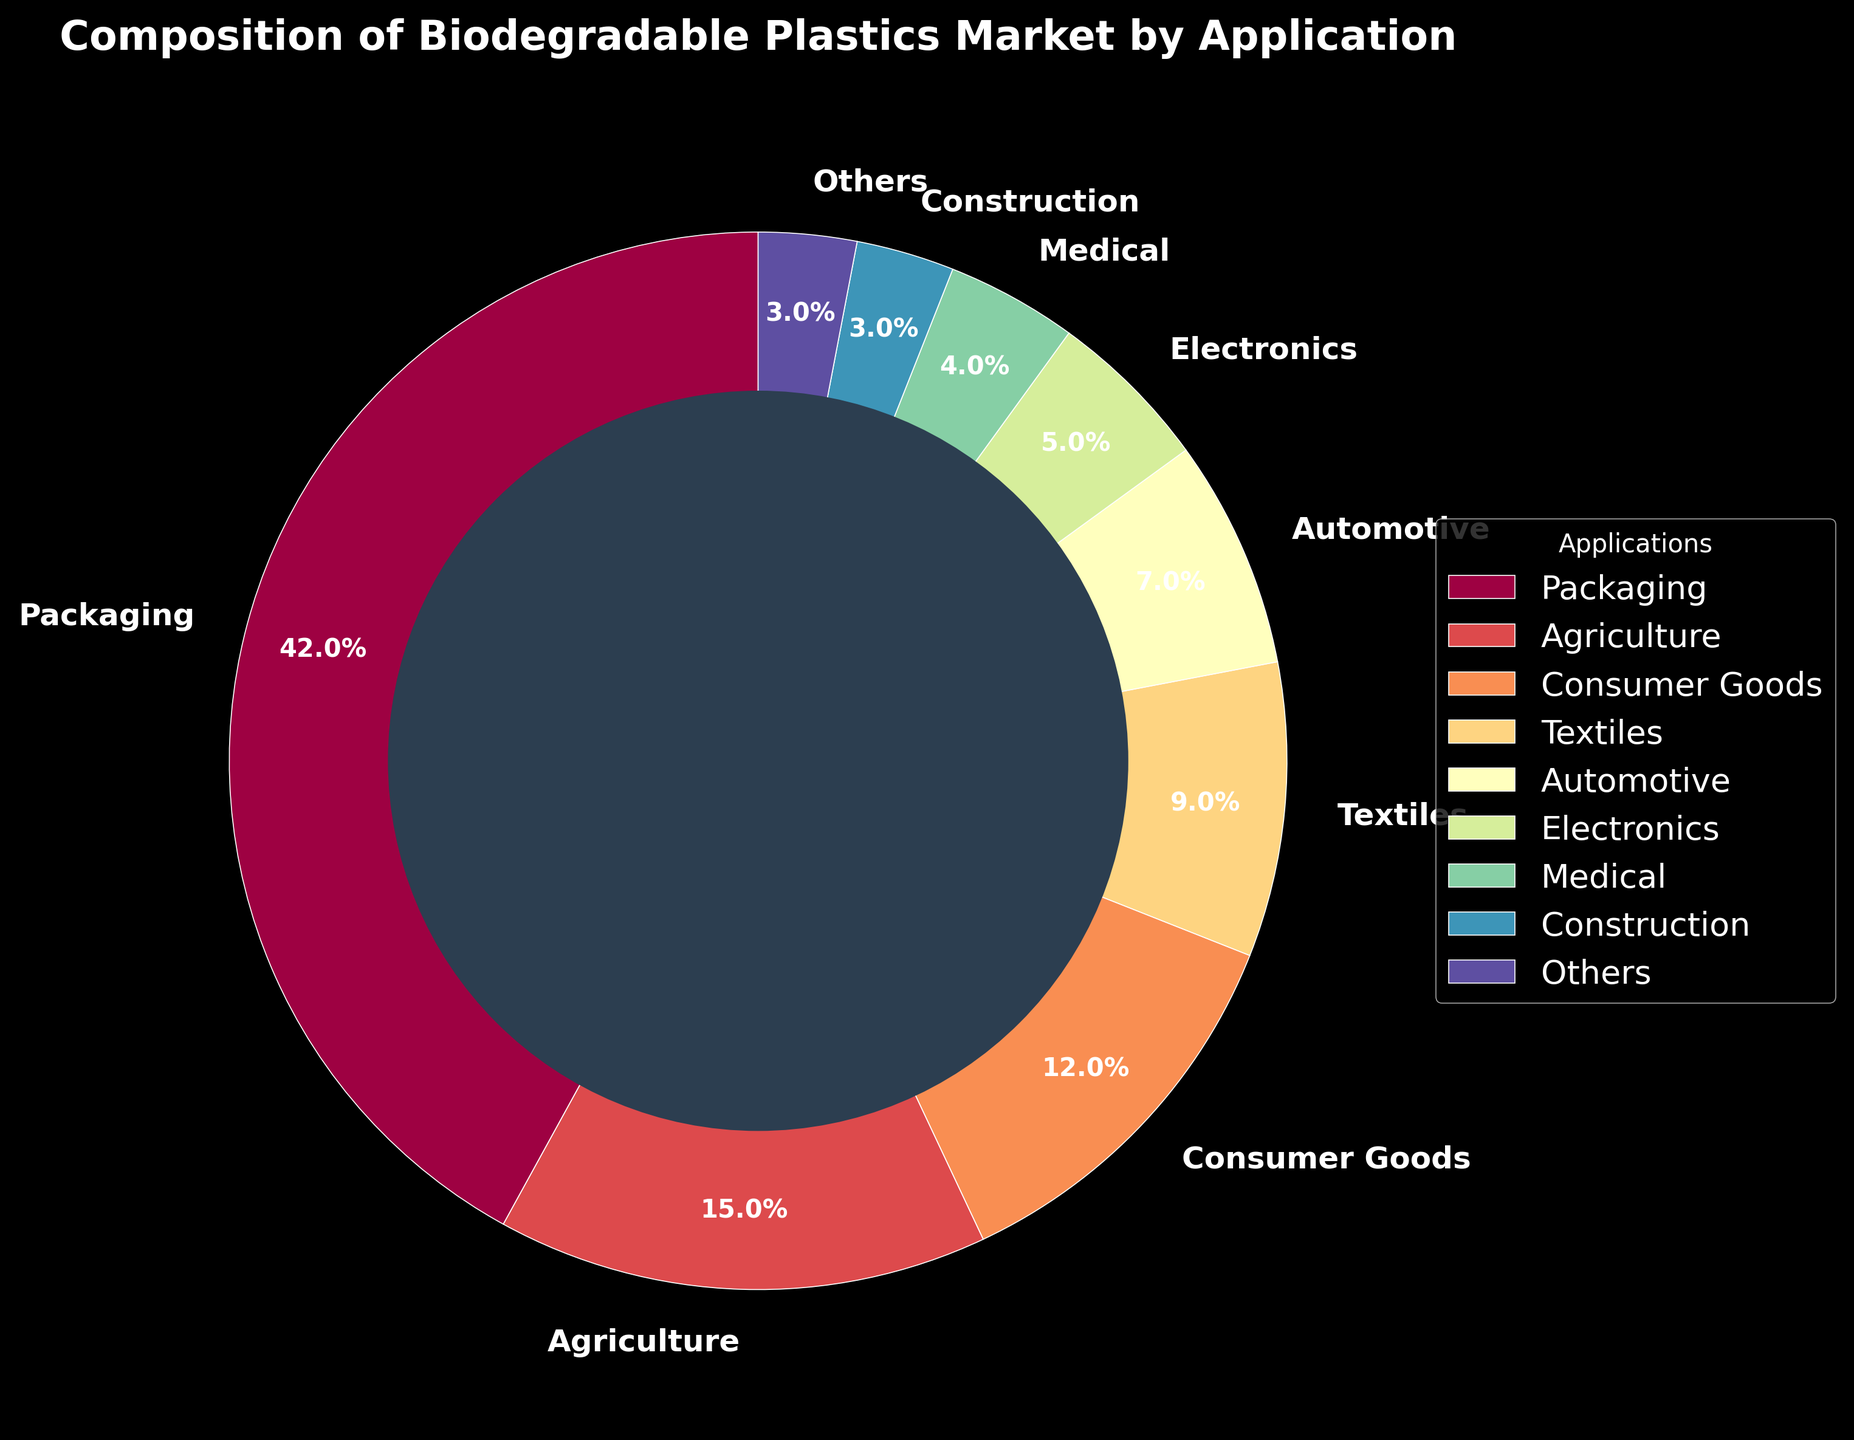Which application has the largest percentage of the biodegradable plastics market? The largest section in the pie chart is for Packaging, so Packaging has the largest percentage.
Answer: Packaging What percentage of the biodegradable plastics market does the Automotive and Medical applications together represent? Sum the percentages of Automotive (7%) and Medical (4%) applications. 7% + 4% = 11%
Answer: 11% How does the percentage of the Electronics application compare to the Consumer Goods application? The percentage for Electronics is 5%, and for Consumer Goods, it is 12%. 5% is less than 12%.
Answer: Less Calculate the total percentage of the biodegradable plastics market taken up by Textiles, Automotive, and Construction applications. Sum the percentages of Textiles (9%), Automotive (7%), and Construction (3%) applications. 9% + 7% + 3% = 19%
Answer: 19% What is the difference between the percentages of the Packaging and Agriculture applications? Subtract the percentage of Agriculture (15%) from Packaging (42%). 42% - 15% = 27%
Answer: 27% Which application constitutes the smallest percentage of the biodegradable plastics market, and what is that percentage? The smallest sections in the pie chart are for Construction and Others, each representing 3%.
Answer: Construction and Others, 3% What applications cumulatively take up more than 50% of the biodegradable plastics market? Sum percentages to find the total. Packaging (42%) + Agriculture (15%) = 57%, which is greater than 50%.
Answer: Packaging and Agriculture Compare the percentages provided for Medical and Others applications. Do they constitute the same percentage? The percentage for Medical is 4% and for Others is 3%. They are not the same.
Answer: No, Medical is 4%, Others is 3% Which applications occupy more than 10% of the biodegradable plastics market? From the chart, Packaging (42%) and Agriculture (15%) both have more than 10%. Consumer Goods at 12% also fits.
Answer: Packaging, Agriculture, and Consumer Goods If the Electronics application doubled its market share, what would its new percentage be? Double the percentage of Electronics (5%) to get the new percentage. 5% * 2 = 10%
Answer: 10% 